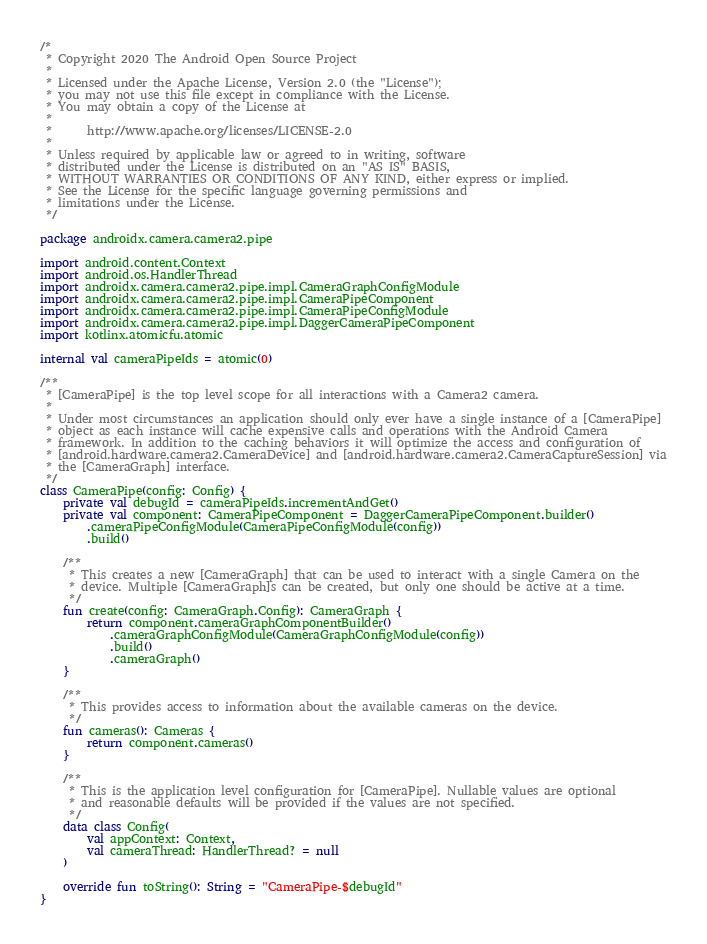Convert code to text. <code><loc_0><loc_0><loc_500><loc_500><_Kotlin_>/*
 * Copyright 2020 The Android Open Source Project
 *
 * Licensed under the Apache License, Version 2.0 (the "License");
 * you may not use this file except in compliance with the License.
 * You may obtain a copy of the License at
 *
 *      http://www.apache.org/licenses/LICENSE-2.0
 *
 * Unless required by applicable law or agreed to in writing, software
 * distributed under the License is distributed on an "AS IS" BASIS,
 * WITHOUT WARRANTIES OR CONDITIONS OF ANY KIND, either express or implied.
 * See the License for the specific language governing permissions and
 * limitations under the License.
 */

package androidx.camera.camera2.pipe

import android.content.Context
import android.os.HandlerThread
import androidx.camera.camera2.pipe.impl.CameraGraphConfigModule
import androidx.camera.camera2.pipe.impl.CameraPipeComponent
import androidx.camera.camera2.pipe.impl.CameraPipeConfigModule
import androidx.camera.camera2.pipe.impl.DaggerCameraPipeComponent
import kotlinx.atomicfu.atomic

internal val cameraPipeIds = atomic(0)

/**
 * [CameraPipe] is the top level scope for all interactions with a Camera2 camera.
 *
 * Under most circumstances an application should only ever have a single instance of a [CameraPipe]
 * object as each instance will cache expensive calls and operations with the Android Camera
 * framework. In addition to the caching behaviors it will optimize the access and configuration of
 * [android.hardware.camera2.CameraDevice] and [android.hardware.camera2.CameraCaptureSession] via
 * the [CameraGraph] interface.
 */
class CameraPipe(config: Config) {
    private val debugId = cameraPipeIds.incrementAndGet()
    private val component: CameraPipeComponent = DaggerCameraPipeComponent.builder()
        .cameraPipeConfigModule(CameraPipeConfigModule(config))
        .build()

    /**
     * This creates a new [CameraGraph] that can be used to interact with a single Camera on the
     * device. Multiple [CameraGraph]s can be created, but only one should be active at a time.
     */
    fun create(config: CameraGraph.Config): CameraGraph {
        return component.cameraGraphComponentBuilder()
            .cameraGraphConfigModule(CameraGraphConfigModule(config))
            .build()
            .cameraGraph()
    }

    /**
     * This provides access to information about the available cameras on the device.
     */
    fun cameras(): Cameras {
        return component.cameras()
    }

    /**
     * This is the application level configuration for [CameraPipe]. Nullable values are optional
     * and reasonable defaults will be provided if the values are not specified.
     */
    data class Config(
        val appContext: Context,
        val cameraThread: HandlerThread? = null
    )

    override fun toString(): String = "CameraPipe-$debugId"
}
</code> 